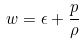Convert formula to latex. <formula><loc_0><loc_0><loc_500><loc_500>w = \epsilon + \frac { p } { \rho }</formula> 